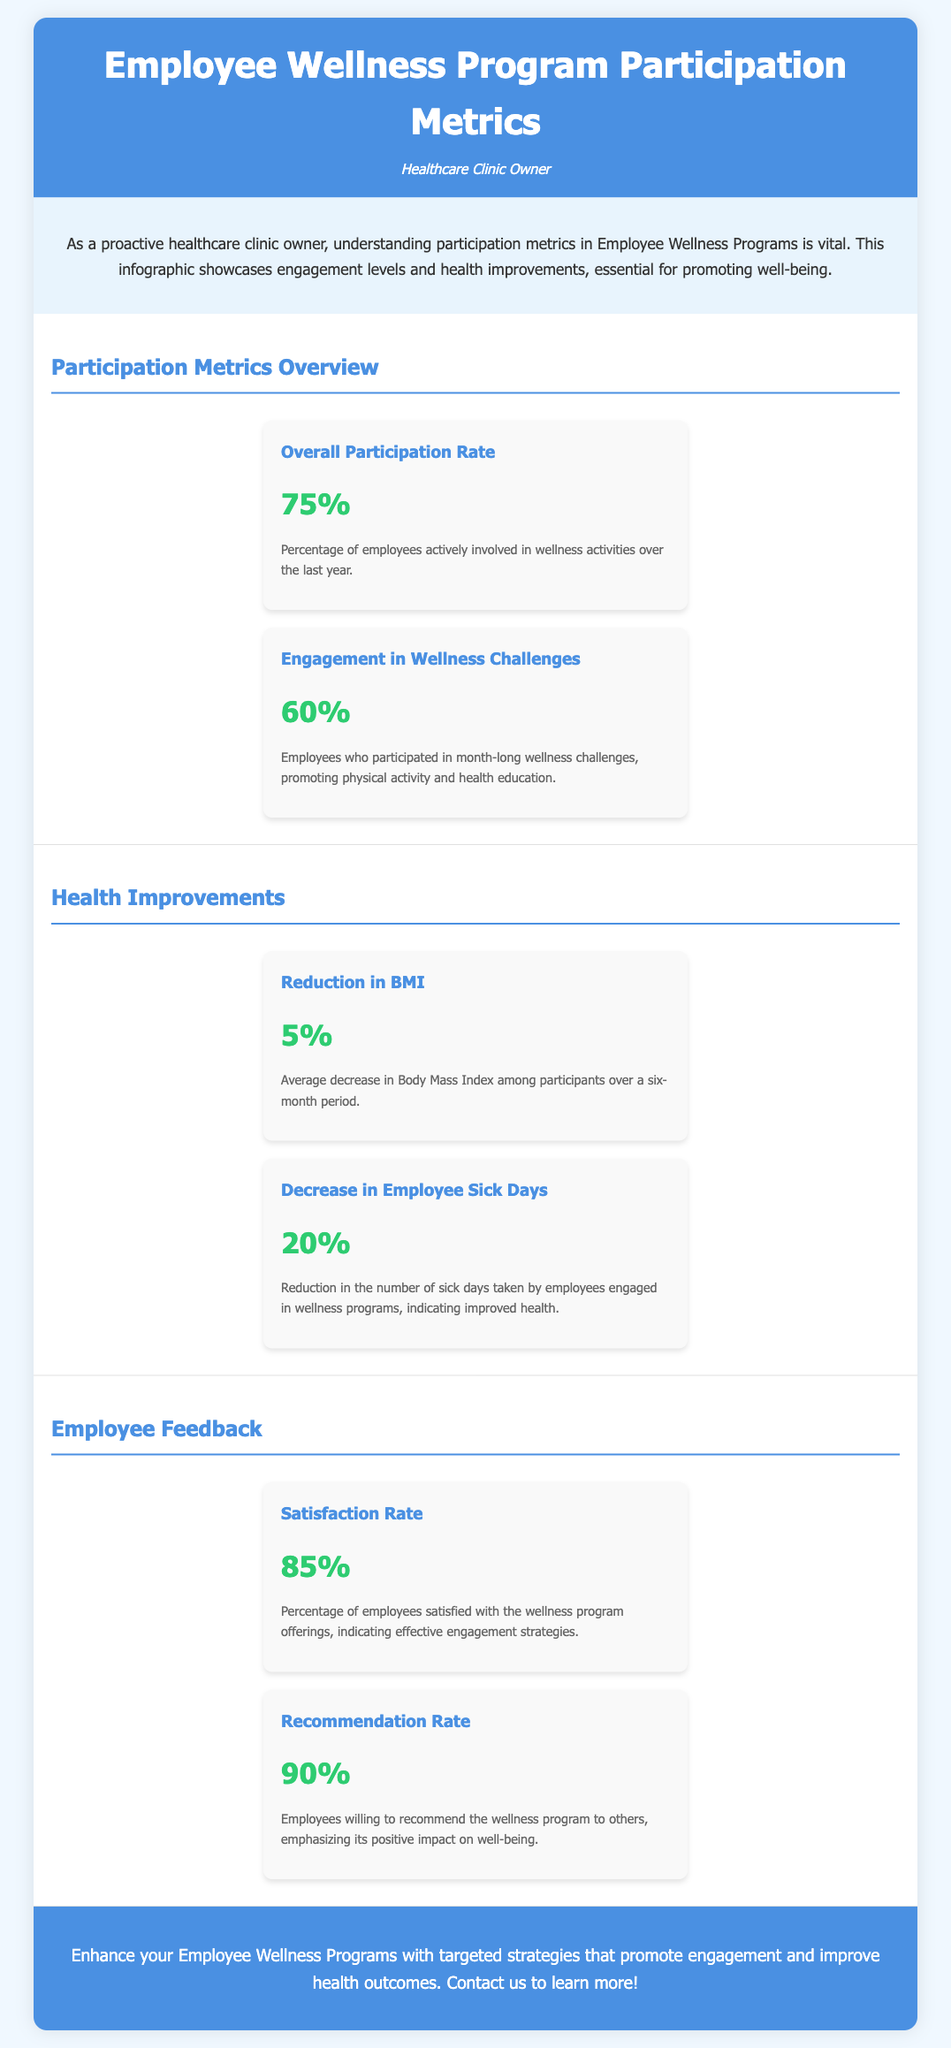What is the overall participation rate? The overall participation rate refers to the percentage of employees actively involved in wellness activities over the last year, which is mentioned in the document.
Answer: 75% What is the satisfaction rate among employees? The satisfaction rate indicates the percentage of employees satisfied with the wellness program offerings, as stated in the document.
Answer: 85% What percentage of employees participated in wellness challenges? This percentage shows the engagement levels in month-long wellness challenges, promoting physical activity and health education.
Answer: 60% What is the average reduction in BMI? The average reduction in Body Mass Index among participants over a six-month period is specified in the document.
Answer: 5% What percentage reduction was observed in employee sick days? The document specifies the reduction in the number of sick days taken by employees engaged in wellness programs.
Answer: 20% What is the recommendation rate for the wellness program? The recommendation rate reflects employees' willingness to recommend the wellness program to others.
Answer: 90% What color is used for the header background? This question looks for specific design details mentioned in the document about the color scheme.
Answer: Blue What is the purpose of the call-to-action section? The call-to-action section highlights the importance of enhancing Employee Wellness Programs with targeted strategies, as outlined in the document.
Answer: Promote engagement 